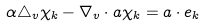<formula> <loc_0><loc_0><loc_500><loc_500>\alpha \triangle _ { v } \chi _ { k } - \nabla _ { v } \cdot a \chi _ { k } = a \cdot e _ { k }</formula> 